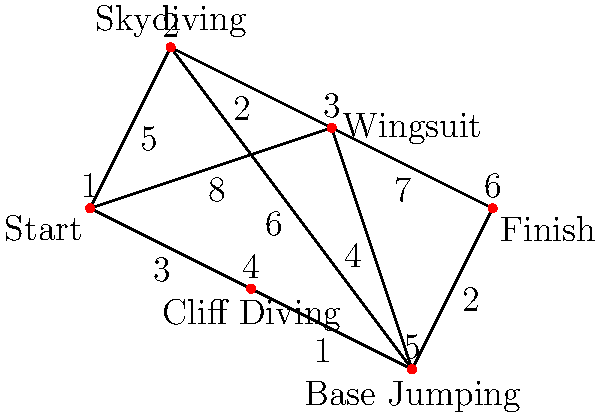You're planning an extreme sports challenge video to outdo your rival adventurer. The graph represents a network of extreme sports locations, with edges showing travel times in hours between locations. Starting from point 1 and ending at point 6, what's the shortest time path through this network that includes at least three extreme sports locations (excluding start and finish)? To solve this problem, we'll use Dijkstra's algorithm to find the shortest path from the start (1) to the finish (6), considering the constraint of visiting at least three extreme sports locations.

Step 1: Identify all possible paths that include at least three extreme sports locations:
- 1 → 2 → 3 → 5 → 6
- 1 → 2 → 5 → 6
- 1 → 3 → 5 → 6
- 1 → 4 → 5 → 6

Step 2: Calculate the total time for each path:
- 1 → 2 → 3 → 5 → 6: 5 + 2 + 4 + 2 = 13 hours
- 1 → 2 → 5 → 6: 5 + 6 + 2 = 13 hours
- 1 → 3 → 5 → 6: 8 + 4 + 2 = 14 hours
- 1 → 4 → 5 → 6: 3 + 1 + 2 = 6 hours

Step 3: Identify the shortest path that meets the criteria:
The path 1 → 4 → 5 → 6 is the shortest at 6 hours and includes three extreme sports locations (Cliff Diving, Base Jumping, and the finish location).

Therefore, the shortest time path through this network that includes at least three extreme sports locations is 1 → 4 → 5 → 6, taking 6 hours.
Answer: 1 → 4 → 5 → 6, 6 hours 